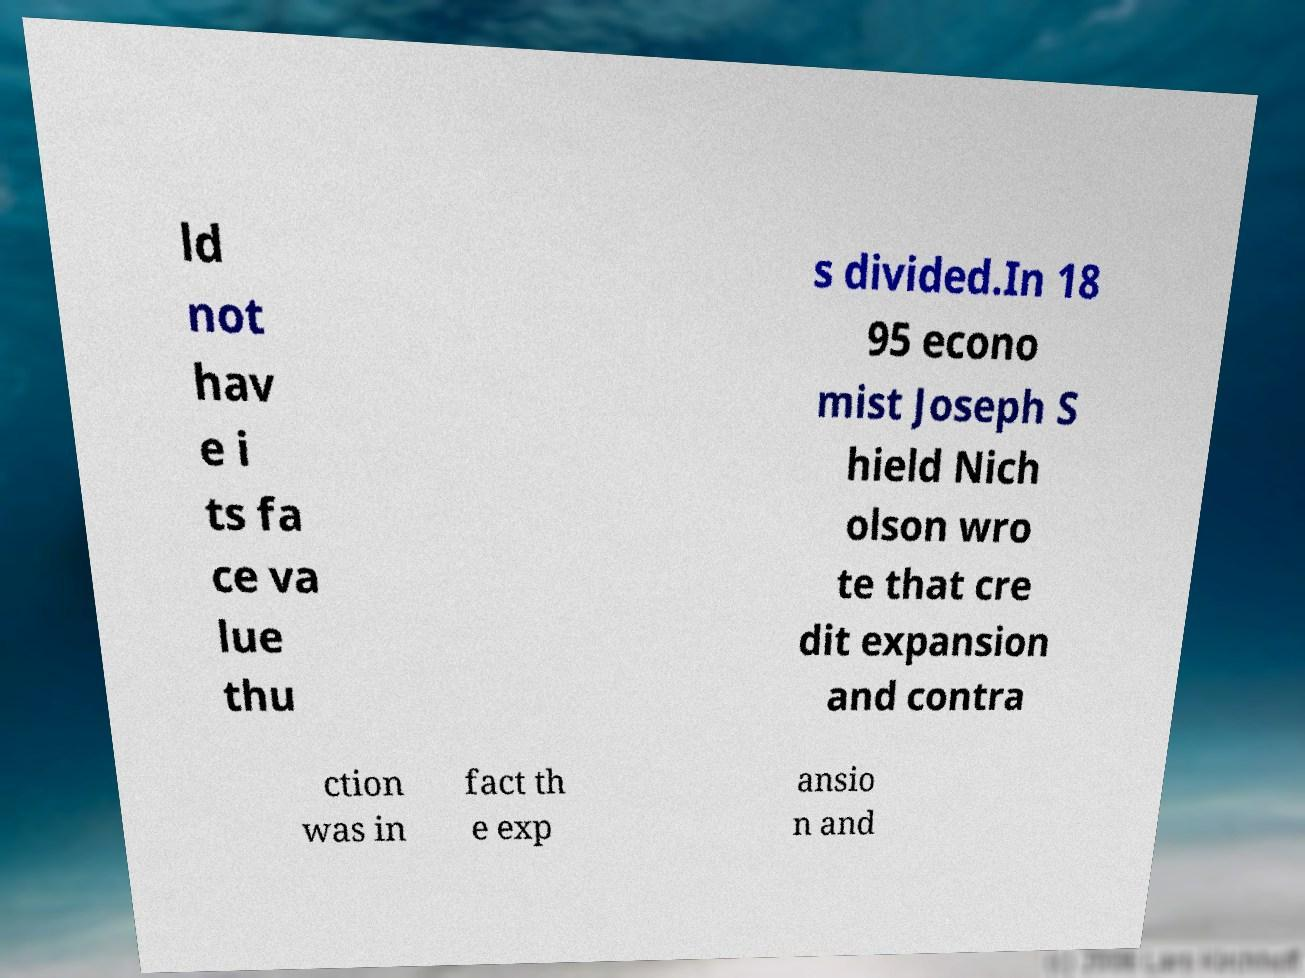Can you read and provide the text displayed in the image?This photo seems to have some interesting text. Can you extract and type it out for me? ld not hav e i ts fa ce va lue thu s divided.In 18 95 econo mist Joseph S hield Nich olson wro te that cre dit expansion and contra ction was in fact th e exp ansio n and 